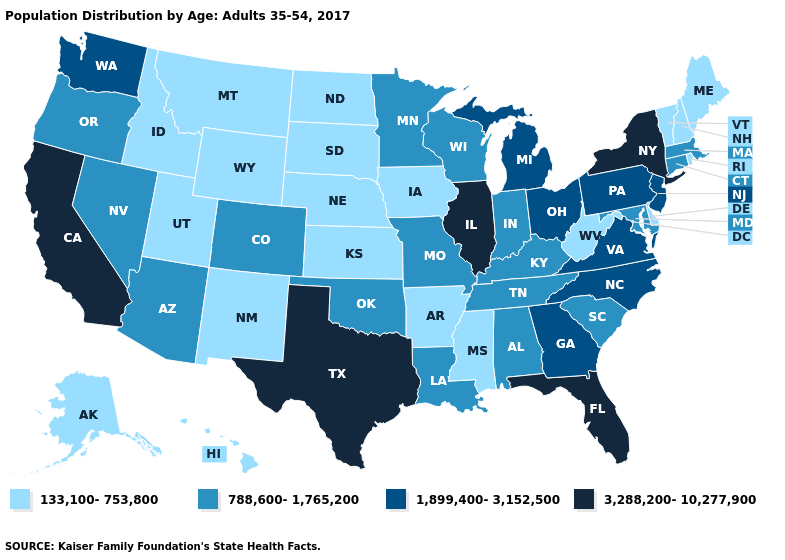Does Illinois have the highest value in the MidWest?
Keep it brief. Yes. How many symbols are there in the legend?
Be succinct. 4. Does Texas have the same value as Alabama?
Answer briefly. No. Does Nevada have a lower value than Pennsylvania?
Short answer required. Yes. What is the highest value in states that border Kansas?
Give a very brief answer. 788,600-1,765,200. What is the value of Iowa?
Be succinct. 133,100-753,800. Does California have the highest value in the USA?
Keep it brief. Yes. Among the states that border Wisconsin , does Illinois have the lowest value?
Keep it brief. No. What is the value of Missouri?
Be succinct. 788,600-1,765,200. What is the highest value in states that border Ohio?
Be succinct. 1,899,400-3,152,500. What is the highest value in the USA?
Keep it brief. 3,288,200-10,277,900. What is the highest value in states that border Texas?
Answer briefly. 788,600-1,765,200. Does Georgia have the lowest value in the USA?
Be succinct. No. Which states hav the highest value in the Northeast?
Quick response, please. New York. Among the states that border Maryland , which have the lowest value?
Concise answer only. Delaware, West Virginia. 